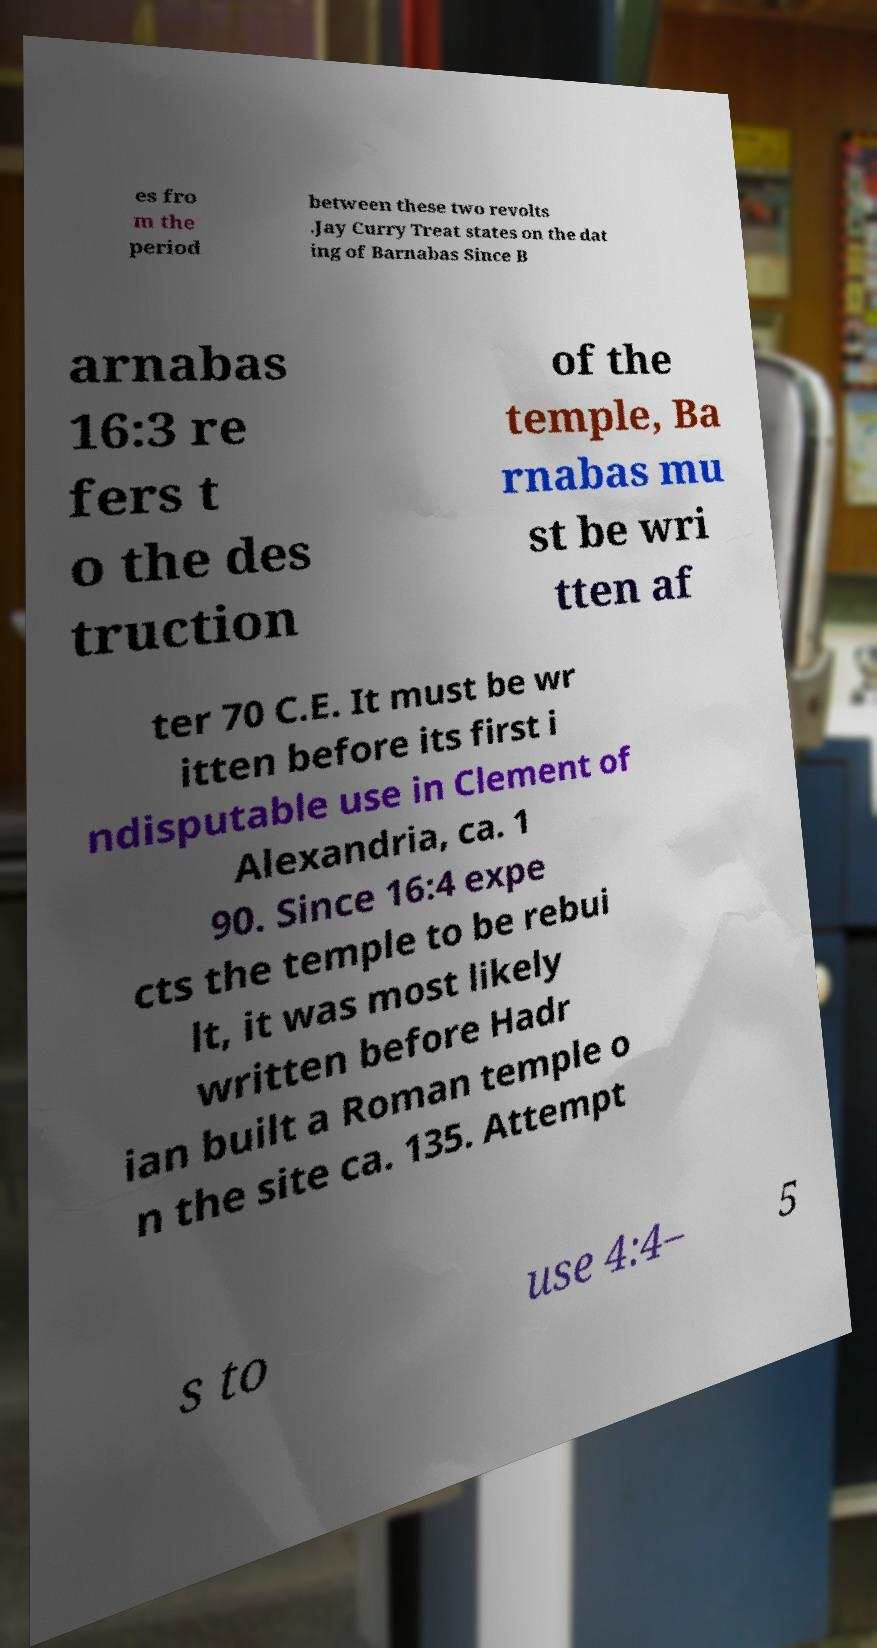Can you read and provide the text displayed in the image?This photo seems to have some interesting text. Can you extract and type it out for me? es fro m the period between these two revolts .Jay Curry Treat states on the dat ing of Barnabas Since B arnabas 16:3 re fers t o the des truction of the temple, Ba rnabas mu st be wri tten af ter 70 C.E. It must be wr itten before its first i ndisputable use in Clement of Alexandria, ca. 1 90. Since 16:4 expe cts the temple to be rebui lt, it was most likely written before Hadr ian built a Roman temple o n the site ca. 135. Attempt s to use 4:4– 5 